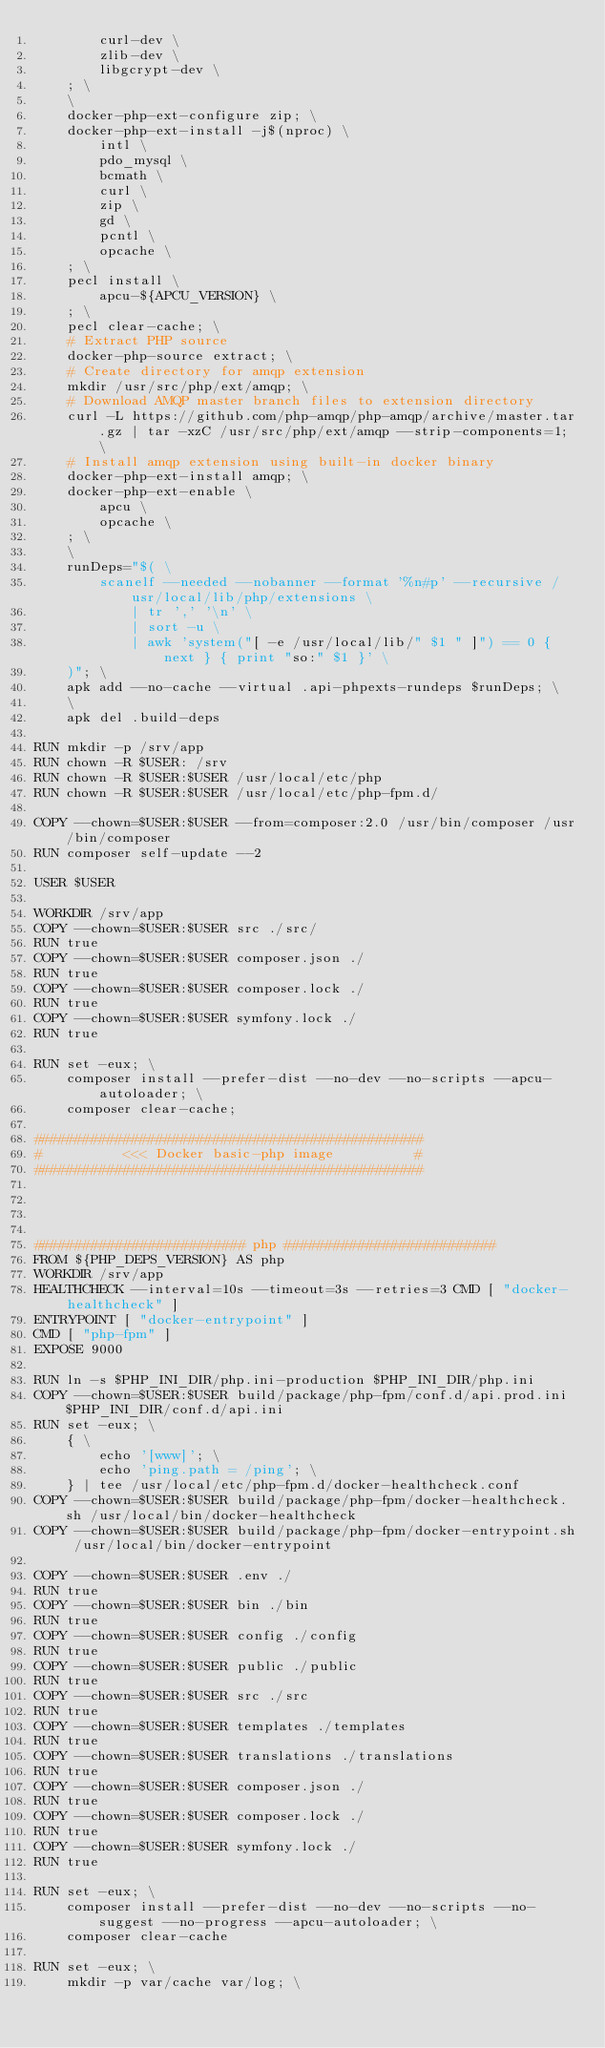Convert code to text. <code><loc_0><loc_0><loc_500><loc_500><_Dockerfile_>		curl-dev \
		zlib-dev \
		libgcrypt-dev \
	; \
	\
	docker-php-ext-configure zip; \
	docker-php-ext-install -j$(nproc) \
		intl \
		pdo_mysql \
		bcmath \
		curl \
		zip \
		gd \
		pcntl \
        opcache \
	; \
	pecl install \
		apcu-${APCU_VERSION} \
	; \
	pecl clear-cache; \
    # Extract PHP source
    docker-php-source extract; \
    # Create directory for amqp extension
    mkdir /usr/src/php/ext/amqp; \
    # Download AMQP master branch files to extension directory
    curl -L https://github.com/php-amqp/php-amqp/archive/master.tar.gz | tar -xzC /usr/src/php/ext/amqp --strip-components=1; \
    # Install amqp extension using built-in docker binary
    docker-php-ext-install amqp; \
    docker-php-ext-enable \
        apcu \
        opcache \
    ; \
	\
	runDeps="$( \
		scanelf --needed --nobanner --format '%n#p' --recursive /usr/local/lib/php/extensions \
			| tr ',' '\n' \
			| sort -u \
			| awk 'system("[ -e /usr/local/lib/" $1 " ]") == 0 { next } { print "so:" $1 }' \
	)"; \
	apk add --no-cache --virtual .api-phpexts-rundeps $runDeps; \
	\
	apk del .build-deps

RUN mkdir -p /srv/app
RUN chown -R $USER: /srv
RUN chown -R $USER:$USER /usr/local/etc/php
RUN chown -R $USER:$USER /usr/local/etc/php-fpm.d/

COPY --chown=$USER:$USER --from=composer:2.0 /usr/bin/composer /usr/bin/composer
RUN composer self-update --2

USER $USER

WORKDIR /srv/app
COPY --chown=$USER:$USER src ./src/
RUN true
COPY --chown=$USER:$USER composer.json ./
RUN true
COPY --chown=$USER:$USER composer.lock ./
RUN true
COPY --chown=$USER:$USER symfony.lock ./
RUN true

RUN set -eux; \
    composer install --prefer-dist --no-dev --no-scripts --apcu-autoloader; \
    composer clear-cache;

################################################
#          <<< Docker basic-php image          #
################################################




########################## php ##########################
FROM ${PHP_DEPS_VERSION} AS php
WORKDIR /srv/app
HEALTHCHECK --interval=10s --timeout=3s --retries=3 CMD [ "docker-healthcheck" ]
ENTRYPOINT [ "docker-entrypoint" ]
CMD [ "php-fpm" ]
EXPOSE 9000

RUN ln -s $PHP_INI_DIR/php.ini-production $PHP_INI_DIR/php.ini
COPY --chown=$USER:$USER build/package/php-fpm/conf.d/api.prod.ini $PHP_INI_DIR/conf.d/api.ini
RUN set -eux; \
    { \
        echo '[www]'; \
        echo 'ping.path = /ping'; \
    } | tee /usr/local/etc/php-fpm.d/docker-healthcheck.conf
COPY --chown=$USER:$USER build/package/php-fpm/docker-healthcheck.sh /usr/local/bin/docker-healthcheck
COPY --chown=$USER:$USER build/package/php-fpm/docker-entrypoint.sh /usr/local/bin/docker-entrypoint

COPY --chown=$USER:$USER .env ./
RUN true
COPY --chown=$USER:$USER bin ./bin
RUN true
COPY --chown=$USER:$USER config ./config
RUN true
COPY --chown=$USER:$USER public ./public
RUN true
COPY --chown=$USER:$USER src ./src
RUN true
COPY --chown=$USER:$USER templates ./templates
RUN true
COPY --chown=$USER:$USER translations ./translations
RUN true
COPY --chown=$USER:$USER composer.json ./
RUN true
COPY --chown=$USER:$USER composer.lock ./
RUN true
COPY --chown=$USER:$USER symfony.lock ./
RUN true

RUN set -eux; \
    composer install --prefer-dist --no-dev --no-scripts --no-suggest --no-progress --apcu-autoloader; \
    composer clear-cache

RUN set -eux; \
	mkdir -p var/cache var/log; \</code> 